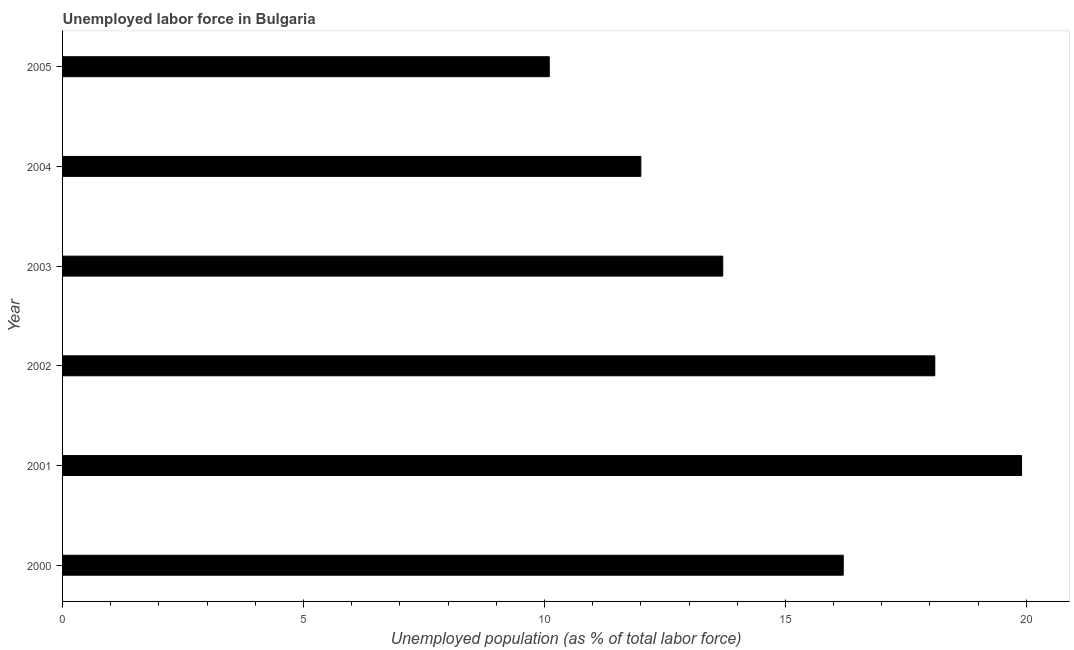What is the title of the graph?
Make the answer very short. Unemployed labor force in Bulgaria. What is the label or title of the X-axis?
Give a very brief answer. Unemployed population (as % of total labor force). Across all years, what is the maximum total unemployed population?
Your response must be concise. 19.9. Across all years, what is the minimum total unemployed population?
Ensure brevity in your answer.  10.1. What is the sum of the total unemployed population?
Offer a very short reply. 90. What is the median total unemployed population?
Keep it short and to the point. 14.95. In how many years, is the total unemployed population greater than 18 %?
Your answer should be very brief. 2. What is the ratio of the total unemployed population in 2000 to that in 2005?
Offer a very short reply. 1.6. Is the total unemployed population in 2000 less than that in 2002?
Make the answer very short. Yes. What is the difference between the highest and the second highest total unemployed population?
Keep it short and to the point. 1.8. Is the sum of the total unemployed population in 2003 and 2004 greater than the maximum total unemployed population across all years?
Provide a short and direct response. Yes. What is the difference between the highest and the lowest total unemployed population?
Provide a short and direct response. 9.8. How many bars are there?
Give a very brief answer. 6. Are all the bars in the graph horizontal?
Offer a terse response. Yes. What is the Unemployed population (as % of total labor force) in 2000?
Provide a short and direct response. 16.2. What is the Unemployed population (as % of total labor force) of 2001?
Your answer should be compact. 19.9. What is the Unemployed population (as % of total labor force) of 2002?
Ensure brevity in your answer.  18.1. What is the Unemployed population (as % of total labor force) in 2003?
Your answer should be very brief. 13.7. What is the Unemployed population (as % of total labor force) in 2005?
Give a very brief answer. 10.1. What is the difference between the Unemployed population (as % of total labor force) in 2000 and 2001?
Provide a succinct answer. -3.7. What is the difference between the Unemployed population (as % of total labor force) in 2000 and 2002?
Your response must be concise. -1.9. What is the difference between the Unemployed population (as % of total labor force) in 2000 and 2004?
Provide a short and direct response. 4.2. What is the difference between the Unemployed population (as % of total labor force) in 2001 and 2002?
Offer a very short reply. 1.8. What is the difference between the Unemployed population (as % of total labor force) in 2002 and 2003?
Give a very brief answer. 4.4. What is the difference between the Unemployed population (as % of total labor force) in 2002 and 2005?
Offer a terse response. 8. What is the difference between the Unemployed population (as % of total labor force) in 2003 and 2004?
Your answer should be compact. 1.7. What is the difference between the Unemployed population (as % of total labor force) in 2004 and 2005?
Your answer should be very brief. 1.9. What is the ratio of the Unemployed population (as % of total labor force) in 2000 to that in 2001?
Your response must be concise. 0.81. What is the ratio of the Unemployed population (as % of total labor force) in 2000 to that in 2002?
Keep it short and to the point. 0.9. What is the ratio of the Unemployed population (as % of total labor force) in 2000 to that in 2003?
Your answer should be very brief. 1.18. What is the ratio of the Unemployed population (as % of total labor force) in 2000 to that in 2004?
Provide a succinct answer. 1.35. What is the ratio of the Unemployed population (as % of total labor force) in 2000 to that in 2005?
Ensure brevity in your answer.  1.6. What is the ratio of the Unemployed population (as % of total labor force) in 2001 to that in 2002?
Your answer should be very brief. 1.1. What is the ratio of the Unemployed population (as % of total labor force) in 2001 to that in 2003?
Your response must be concise. 1.45. What is the ratio of the Unemployed population (as % of total labor force) in 2001 to that in 2004?
Make the answer very short. 1.66. What is the ratio of the Unemployed population (as % of total labor force) in 2001 to that in 2005?
Make the answer very short. 1.97. What is the ratio of the Unemployed population (as % of total labor force) in 2002 to that in 2003?
Offer a terse response. 1.32. What is the ratio of the Unemployed population (as % of total labor force) in 2002 to that in 2004?
Make the answer very short. 1.51. What is the ratio of the Unemployed population (as % of total labor force) in 2002 to that in 2005?
Your response must be concise. 1.79. What is the ratio of the Unemployed population (as % of total labor force) in 2003 to that in 2004?
Your answer should be compact. 1.14. What is the ratio of the Unemployed population (as % of total labor force) in 2003 to that in 2005?
Provide a succinct answer. 1.36. What is the ratio of the Unemployed population (as % of total labor force) in 2004 to that in 2005?
Provide a short and direct response. 1.19. 